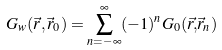Convert formula to latex. <formula><loc_0><loc_0><loc_500><loc_500>G _ { w } ( \vec { r } , \vec { r } _ { 0 } ) = \sum _ { n = - \infty } ^ { \infty } ( - 1 ) ^ { n } G _ { 0 } ( \vec { r , } \vec { r } _ { n } )</formula> 